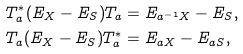Convert formula to latex. <formula><loc_0><loc_0><loc_500><loc_500>T _ { a } ^ { * } ( E _ { X } - E _ { S } ) T _ { a } & = E _ { a ^ { - 1 } X } - E _ { S } , \\ T _ { a } ( E _ { X } - E _ { S } ) T _ { a } ^ { * } & = E _ { a X } - E _ { a S } ,</formula> 